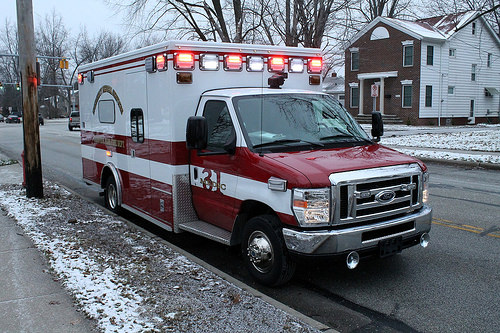<image>
Can you confirm if the ambulence is on the tires? Yes. Looking at the image, I can see the ambulence is positioned on top of the tires, with the tires providing support. Where is the light in relation to the truck? Is it on the truck? Yes. Looking at the image, I can see the light is positioned on top of the truck, with the truck providing support. 